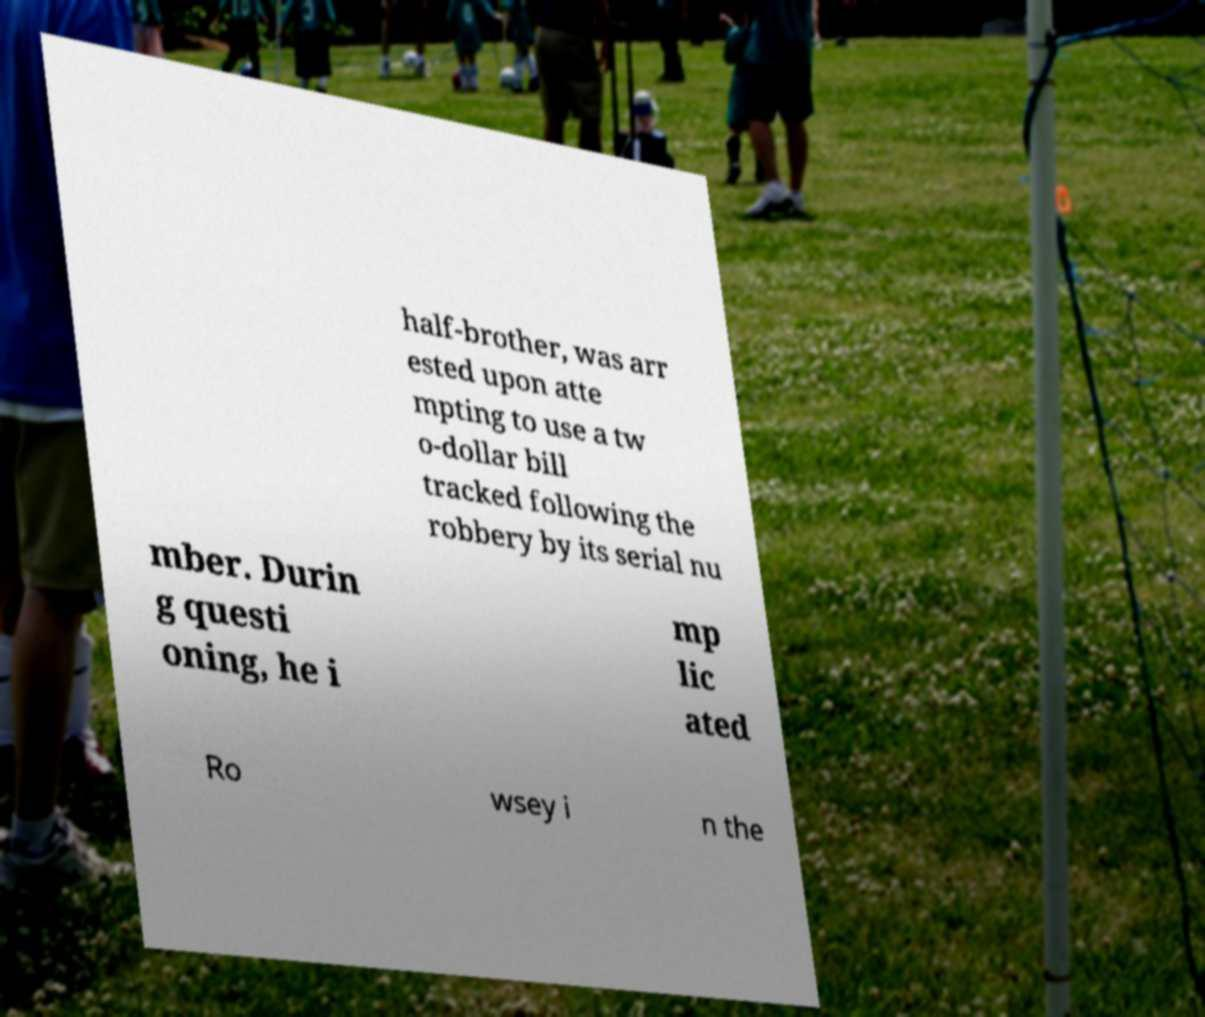Can you accurately transcribe the text from the provided image for me? half-brother, was arr ested upon atte mpting to use a tw o-dollar bill tracked following the robbery by its serial nu mber. Durin g questi oning, he i mp lic ated Ro wsey i n the 